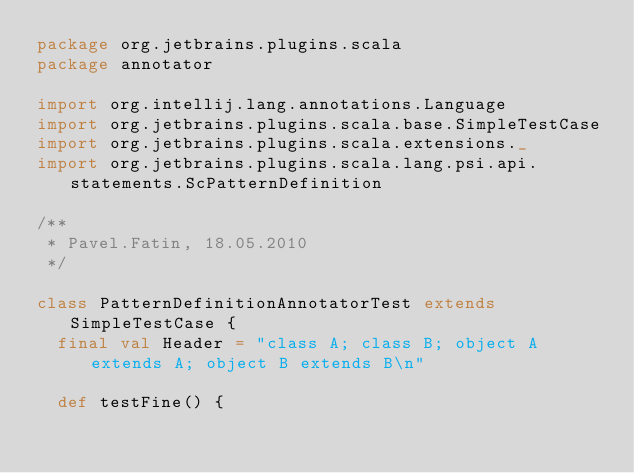<code> <loc_0><loc_0><loc_500><loc_500><_Scala_>package org.jetbrains.plugins.scala
package annotator

import org.intellij.lang.annotations.Language
import org.jetbrains.plugins.scala.base.SimpleTestCase
import org.jetbrains.plugins.scala.extensions._
import org.jetbrains.plugins.scala.lang.psi.api.statements.ScPatternDefinition

/**
 * Pavel.Fatin, 18.05.2010
 */

class PatternDefinitionAnnotatorTest extends SimpleTestCase {
  final val Header = "class A; class B; object A extends A; object B extends B\n"

  def testFine() {</code> 